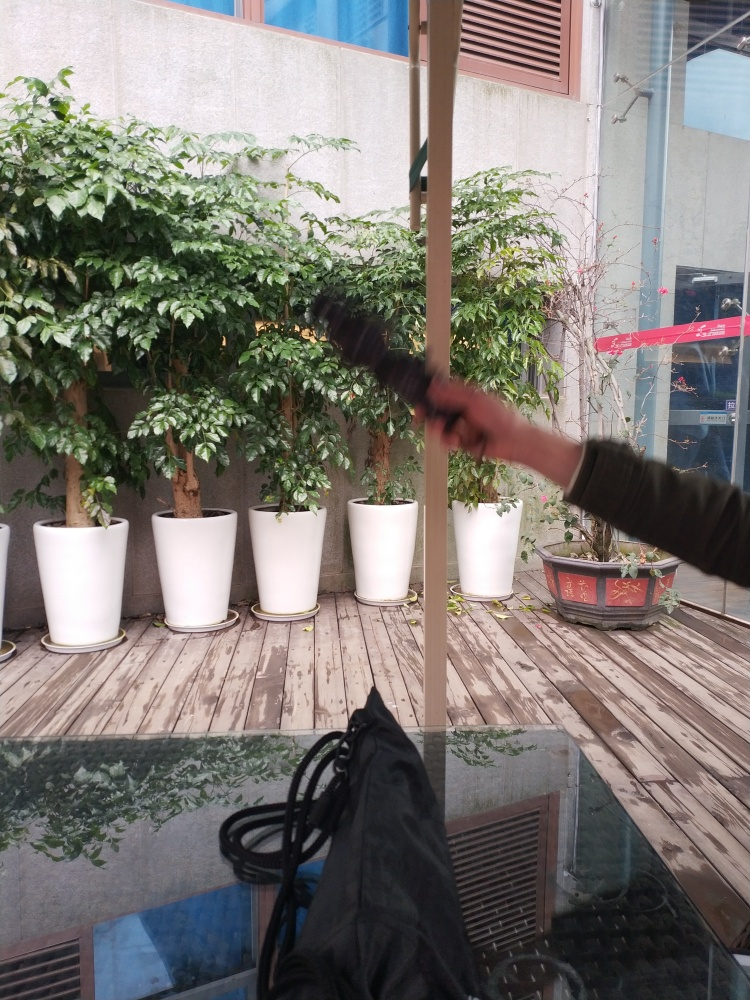What kinds of plants are in the background? The plants in the background have lush, green foliage which suggests they could be a type of evergreen shrub, potentially used for indoor decoration and air purification. However, without more specific details or a closer view, it is difficult to identify the exact species. 